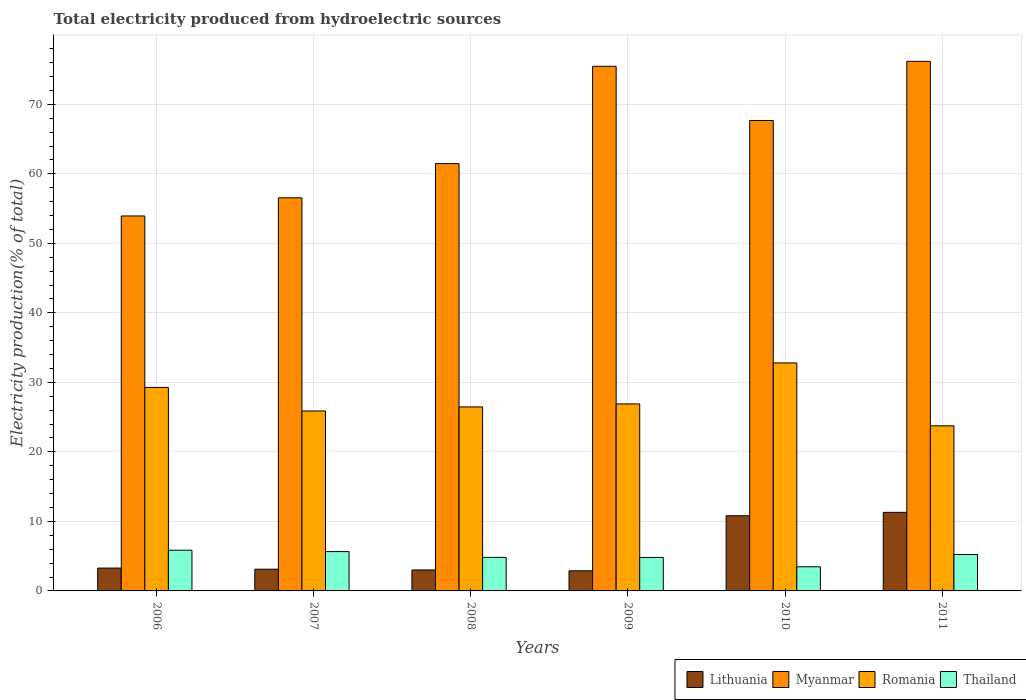How many groups of bars are there?
Your answer should be compact. 6. Are the number of bars on each tick of the X-axis equal?
Make the answer very short. Yes. What is the label of the 1st group of bars from the left?
Make the answer very short. 2006. In how many cases, is the number of bars for a given year not equal to the number of legend labels?
Offer a terse response. 0. What is the total electricity produced in Myanmar in 2008?
Offer a very short reply. 61.48. Across all years, what is the maximum total electricity produced in Romania?
Keep it short and to the point. 32.8. Across all years, what is the minimum total electricity produced in Thailand?
Your answer should be compact. 3.47. In which year was the total electricity produced in Lithuania maximum?
Your answer should be compact. 2011. In which year was the total electricity produced in Lithuania minimum?
Give a very brief answer. 2009. What is the total total electricity produced in Thailand in the graph?
Keep it short and to the point. 29.86. What is the difference between the total electricity produced in Myanmar in 2007 and that in 2009?
Your answer should be very brief. -18.92. What is the difference between the total electricity produced in Lithuania in 2007 and the total electricity produced in Myanmar in 2009?
Make the answer very short. -72.35. What is the average total electricity produced in Romania per year?
Provide a succinct answer. 27.52. In the year 2010, what is the difference between the total electricity produced in Romania and total electricity produced in Lithuania?
Give a very brief answer. 21.99. What is the ratio of the total electricity produced in Romania in 2007 to that in 2011?
Offer a terse response. 1.09. Is the total electricity produced in Lithuania in 2006 less than that in 2007?
Offer a very short reply. No. Is the difference between the total electricity produced in Romania in 2007 and 2011 greater than the difference between the total electricity produced in Lithuania in 2007 and 2011?
Ensure brevity in your answer.  Yes. What is the difference between the highest and the second highest total electricity produced in Thailand?
Your response must be concise. 0.2. What is the difference between the highest and the lowest total electricity produced in Thailand?
Keep it short and to the point. 2.39. In how many years, is the total electricity produced in Myanmar greater than the average total electricity produced in Myanmar taken over all years?
Give a very brief answer. 3. What does the 2nd bar from the left in 2010 represents?
Make the answer very short. Myanmar. What does the 4th bar from the right in 2010 represents?
Your response must be concise. Lithuania. How many bars are there?
Your response must be concise. 24. How many years are there in the graph?
Keep it short and to the point. 6. What is the difference between two consecutive major ticks on the Y-axis?
Your answer should be very brief. 10. Does the graph contain any zero values?
Keep it short and to the point. No. What is the title of the graph?
Your response must be concise. Total electricity produced from hydroelectric sources. What is the label or title of the Y-axis?
Your answer should be very brief. Electricity production(% of total). What is the Electricity production(% of total) in Lithuania in 2006?
Make the answer very short. 3.29. What is the Electricity production(% of total) of Myanmar in 2006?
Your answer should be compact. 53.94. What is the Electricity production(% of total) in Romania in 2006?
Offer a very short reply. 29.28. What is the Electricity production(% of total) of Thailand in 2006?
Your response must be concise. 5.86. What is the Electricity production(% of total) in Lithuania in 2007?
Offer a very short reply. 3.13. What is the Electricity production(% of total) of Myanmar in 2007?
Provide a short and direct response. 56.56. What is the Electricity production(% of total) in Romania in 2007?
Provide a succinct answer. 25.89. What is the Electricity production(% of total) in Thailand in 2007?
Offer a terse response. 5.66. What is the Electricity production(% of total) of Lithuania in 2008?
Your answer should be compact. 3.02. What is the Electricity production(% of total) in Myanmar in 2008?
Provide a short and direct response. 61.48. What is the Electricity production(% of total) in Romania in 2008?
Your answer should be very brief. 26.47. What is the Electricity production(% of total) of Thailand in 2008?
Provide a short and direct response. 4.82. What is the Electricity production(% of total) in Lithuania in 2009?
Give a very brief answer. 2.9. What is the Electricity production(% of total) in Myanmar in 2009?
Offer a terse response. 75.47. What is the Electricity production(% of total) in Romania in 2009?
Offer a terse response. 26.9. What is the Electricity production(% of total) in Thailand in 2009?
Your answer should be very brief. 4.82. What is the Electricity production(% of total) of Lithuania in 2010?
Provide a short and direct response. 10.81. What is the Electricity production(% of total) of Myanmar in 2010?
Give a very brief answer. 67.68. What is the Electricity production(% of total) of Romania in 2010?
Give a very brief answer. 32.8. What is the Electricity production(% of total) of Thailand in 2010?
Provide a succinct answer. 3.47. What is the Electricity production(% of total) in Lithuania in 2011?
Offer a terse response. 11.3. What is the Electricity production(% of total) of Myanmar in 2011?
Your answer should be compact. 76.19. What is the Electricity production(% of total) in Romania in 2011?
Make the answer very short. 23.76. What is the Electricity production(% of total) of Thailand in 2011?
Keep it short and to the point. 5.23. Across all years, what is the maximum Electricity production(% of total) in Lithuania?
Offer a very short reply. 11.3. Across all years, what is the maximum Electricity production(% of total) in Myanmar?
Your answer should be compact. 76.19. Across all years, what is the maximum Electricity production(% of total) in Romania?
Make the answer very short. 32.8. Across all years, what is the maximum Electricity production(% of total) in Thailand?
Offer a very short reply. 5.86. Across all years, what is the minimum Electricity production(% of total) in Lithuania?
Your answer should be very brief. 2.9. Across all years, what is the minimum Electricity production(% of total) of Myanmar?
Keep it short and to the point. 53.94. Across all years, what is the minimum Electricity production(% of total) of Romania?
Offer a terse response. 23.76. Across all years, what is the minimum Electricity production(% of total) in Thailand?
Keep it short and to the point. 3.47. What is the total Electricity production(% of total) in Lithuania in the graph?
Ensure brevity in your answer.  34.44. What is the total Electricity production(% of total) of Myanmar in the graph?
Your answer should be compact. 391.31. What is the total Electricity production(% of total) of Romania in the graph?
Make the answer very short. 165.1. What is the total Electricity production(% of total) of Thailand in the graph?
Your answer should be very brief. 29.86. What is the difference between the Electricity production(% of total) of Lithuania in 2006 and that in 2007?
Keep it short and to the point. 0.16. What is the difference between the Electricity production(% of total) in Myanmar in 2006 and that in 2007?
Your answer should be very brief. -2.61. What is the difference between the Electricity production(% of total) in Romania in 2006 and that in 2007?
Your answer should be very brief. 3.39. What is the difference between the Electricity production(% of total) of Thailand in 2006 and that in 2007?
Offer a very short reply. 0.2. What is the difference between the Electricity production(% of total) in Lithuania in 2006 and that in 2008?
Give a very brief answer. 0.27. What is the difference between the Electricity production(% of total) in Myanmar in 2006 and that in 2008?
Keep it short and to the point. -7.53. What is the difference between the Electricity production(% of total) in Romania in 2006 and that in 2008?
Ensure brevity in your answer.  2.81. What is the difference between the Electricity production(% of total) in Thailand in 2006 and that in 2008?
Your answer should be compact. 1.03. What is the difference between the Electricity production(% of total) of Lithuania in 2006 and that in 2009?
Offer a terse response. 0.39. What is the difference between the Electricity production(% of total) in Myanmar in 2006 and that in 2009?
Offer a very short reply. -21.53. What is the difference between the Electricity production(% of total) of Romania in 2006 and that in 2009?
Make the answer very short. 2.37. What is the difference between the Electricity production(% of total) in Thailand in 2006 and that in 2009?
Provide a succinct answer. 1.04. What is the difference between the Electricity production(% of total) in Lithuania in 2006 and that in 2010?
Offer a very short reply. -7.53. What is the difference between the Electricity production(% of total) of Myanmar in 2006 and that in 2010?
Your response must be concise. -13.74. What is the difference between the Electricity production(% of total) of Romania in 2006 and that in 2010?
Your answer should be compact. -3.52. What is the difference between the Electricity production(% of total) of Thailand in 2006 and that in 2010?
Ensure brevity in your answer.  2.39. What is the difference between the Electricity production(% of total) of Lithuania in 2006 and that in 2011?
Your answer should be very brief. -8.02. What is the difference between the Electricity production(% of total) of Myanmar in 2006 and that in 2011?
Offer a very short reply. -22.24. What is the difference between the Electricity production(% of total) of Romania in 2006 and that in 2011?
Your answer should be compact. 5.52. What is the difference between the Electricity production(% of total) in Thailand in 2006 and that in 2011?
Your answer should be very brief. 0.62. What is the difference between the Electricity production(% of total) in Lithuania in 2007 and that in 2008?
Ensure brevity in your answer.  0.11. What is the difference between the Electricity production(% of total) in Myanmar in 2007 and that in 2008?
Keep it short and to the point. -4.92. What is the difference between the Electricity production(% of total) in Romania in 2007 and that in 2008?
Offer a terse response. -0.58. What is the difference between the Electricity production(% of total) in Thailand in 2007 and that in 2008?
Your answer should be very brief. 0.83. What is the difference between the Electricity production(% of total) in Lithuania in 2007 and that in 2009?
Give a very brief answer. 0.23. What is the difference between the Electricity production(% of total) of Myanmar in 2007 and that in 2009?
Your response must be concise. -18.92. What is the difference between the Electricity production(% of total) in Romania in 2007 and that in 2009?
Ensure brevity in your answer.  -1.01. What is the difference between the Electricity production(% of total) of Thailand in 2007 and that in 2009?
Make the answer very short. 0.84. What is the difference between the Electricity production(% of total) of Lithuania in 2007 and that in 2010?
Your answer should be compact. -7.69. What is the difference between the Electricity production(% of total) in Myanmar in 2007 and that in 2010?
Give a very brief answer. -11.12. What is the difference between the Electricity production(% of total) in Romania in 2007 and that in 2010?
Your response must be concise. -6.91. What is the difference between the Electricity production(% of total) of Thailand in 2007 and that in 2010?
Your answer should be very brief. 2.19. What is the difference between the Electricity production(% of total) of Lithuania in 2007 and that in 2011?
Your answer should be compact. -8.18. What is the difference between the Electricity production(% of total) in Myanmar in 2007 and that in 2011?
Offer a very short reply. -19.63. What is the difference between the Electricity production(% of total) in Romania in 2007 and that in 2011?
Your response must be concise. 2.13. What is the difference between the Electricity production(% of total) of Thailand in 2007 and that in 2011?
Your response must be concise. 0.43. What is the difference between the Electricity production(% of total) in Lithuania in 2008 and that in 2009?
Ensure brevity in your answer.  0.12. What is the difference between the Electricity production(% of total) in Myanmar in 2008 and that in 2009?
Your answer should be very brief. -14. What is the difference between the Electricity production(% of total) of Romania in 2008 and that in 2009?
Your answer should be very brief. -0.43. What is the difference between the Electricity production(% of total) of Thailand in 2008 and that in 2009?
Ensure brevity in your answer.  0.01. What is the difference between the Electricity production(% of total) in Lithuania in 2008 and that in 2010?
Give a very brief answer. -7.8. What is the difference between the Electricity production(% of total) of Myanmar in 2008 and that in 2010?
Ensure brevity in your answer.  -6.2. What is the difference between the Electricity production(% of total) in Romania in 2008 and that in 2010?
Your answer should be compact. -6.33. What is the difference between the Electricity production(% of total) in Thailand in 2008 and that in 2010?
Your answer should be compact. 1.35. What is the difference between the Electricity production(% of total) of Lithuania in 2008 and that in 2011?
Provide a short and direct response. -8.29. What is the difference between the Electricity production(% of total) of Myanmar in 2008 and that in 2011?
Provide a short and direct response. -14.71. What is the difference between the Electricity production(% of total) of Romania in 2008 and that in 2011?
Provide a succinct answer. 2.72. What is the difference between the Electricity production(% of total) of Thailand in 2008 and that in 2011?
Your answer should be very brief. -0.41. What is the difference between the Electricity production(% of total) of Lithuania in 2009 and that in 2010?
Give a very brief answer. -7.92. What is the difference between the Electricity production(% of total) in Myanmar in 2009 and that in 2010?
Provide a short and direct response. 7.8. What is the difference between the Electricity production(% of total) of Romania in 2009 and that in 2010?
Offer a terse response. -5.9. What is the difference between the Electricity production(% of total) of Thailand in 2009 and that in 2010?
Offer a very short reply. 1.35. What is the difference between the Electricity production(% of total) of Lithuania in 2009 and that in 2011?
Ensure brevity in your answer.  -8.41. What is the difference between the Electricity production(% of total) of Myanmar in 2009 and that in 2011?
Offer a terse response. -0.71. What is the difference between the Electricity production(% of total) in Romania in 2009 and that in 2011?
Your answer should be very brief. 3.15. What is the difference between the Electricity production(% of total) of Thailand in 2009 and that in 2011?
Provide a short and direct response. -0.42. What is the difference between the Electricity production(% of total) of Lithuania in 2010 and that in 2011?
Offer a very short reply. -0.49. What is the difference between the Electricity production(% of total) in Myanmar in 2010 and that in 2011?
Offer a terse response. -8.51. What is the difference between the Electricity production(% of total) in Romania in 2010 and that in 2011?
Your answer should be compact. 9.04. What is the difference between the Electricity production(% of total) in Thailand in 2010 and that in 2011?
Provide a succinct answer. -1.76. What is the difference between the Electricity production(% of total) in Lithuania in 2006 and the Electricity production(% of total) in Myanmar in 2007?
Provide a short and direct response. -53.27. What is the difference between the Electricity production(% of total) of Lithuania in 2006 and the Electricity production(% of total) of Romania in 2007?
Your answer should be very brief. -22.6. What is the difference between the Electricity production(% of total) of Lithuania in 2006 and the Electricity production(% of total) of Thailand in 2007?
Keep it short and to the point. -2.37. What is the difference between the Electricity production(% of total) in Myanmar in 2006 and the Electricity production(% of total) in Romania in 2007?
Make the answer very short. 28.05. What is the difference between the Electricity production(% of total) in Myanmar in 2006 and the Electricity production(% of total) in Thailand in 2007?
Give a very brief answer. 48.28. What is the difference between the Electricity production(% of total) of Romania in 2006 and the Electricity production(% of total) of Thailand in 2007?
Give a very brief answer. 23.62. What is the difference between the Electricity production(% of total) of Lithuania in 2006 and the Electricity production(% of total) of Myanmar in 2008?
Ensure brevity in your answer.  -58.19. What is the difference between the Electricity production(% of total) in Lithuania in 2006 and the Electricity production(% of total) in Romania in 2008?
Make the answer very short. -23.18. What is the difference between the Electricity production(% of total) of Lithuania in 2006 and the Electricity production(% of total) of Thailand in 2008?
Your answer should be compact. -1.54. What is the difference between the Electricity production(% of total) of Myanmar in 2006 and the Electricity production(% of total) of Romania in 2008?
Offer a very short reply. 27.47. What is the difference between the Electricity production(% of total) of Myanmar in 2006 and the Electricity production(% of total) of Thailand in 2008?
Make the answer very short. 49.12. What is the difference between the Electricity production(% of total) of Romania in 2006 and the Electricity production(% of total) of Thailand in 2008?
Make the answer very short. 24.45. What is the difference between the Electricity production(% of total) in Lithuania in 2006 and the Electricity production(% of total) in Myanmar in 2009?
Give a very brief answer. -72.19. What is the difference between the Electricity production(% of total) of Lithuania in 2006 and the Electricity production(% of total) of Romania in 2009?
Make the answer very short. -23.62. What is the difference between the Electricity production(% of total) in Lithuania in 2006 and the Electricity production(% of total) in Thailand in 2009?
Your answer should be very brief. -1.53. What is the difference between the Electricity production(% of total) of Myanmar in 2006 and the Electricity production(% of total) of Romania in 2009?
Provide a succinct answer. 27.04. What is the difference between the Electricity production(% of total) of Myanmar in 2006 and the Electricity production(% of total) of Thailand in 2009?
Make the answer very short. 49.13. What is the difference between the Electricity production(% of total) of Romania in 2006 and the Electricity production(% of total) of Thailand in 2009?
Your answer should be very brief. 24.46. What is the difference between the Electricity production(% of total) in Lithuania in 2006 and the Electricity production(% of total) in Myanmar in 2010?
Keep it short and to the point. -64.39. What is the difference between the Electricity production(% of total) of Lithuania in 2006 and the Electricity production(% of total) of Romania in 2010?
Offer a very short reply. -29.51. What is the difference between the Electricity production(% of total) in Lithuania in 2006 and the Electricity production(% of total) in Thailand in 2010?
Keep it short and to the point. -0.18. What is the difference between the Electricity production(% of total) in Myanmar in 2006 and the Electricity production(% of total) in Romania in 2010?
Provide a succinct answer. 21.14. What is the difference between the Electricity production(% of total) in Myanmar in 2006 and the Electricity production(% of total) in Thailand in 2010?
Your response must be concise. 50.47. What is the difference between the Electricity production(% of total) of Romania in 2006 and the Electricity production(% of total) of Thailand in 2010?
Give a very brief answer. 25.81. What is the difference between the Electricity production(% of total) in Lithuania in 2006 and the Electricity production(% of total) in Myanmar in 2011?
Offer a very short reply. -72.9. What is the difference between the Electricity production(% of total) of Lithuania in 2006 and the Electricity production(% of total) of Romania in 2011?
Give a very brief answer. -20.47. What is the difference between the Electricity production(% of total) in Lithuania in 2006 and the Electricity production(% of total) in Thailand in 2011?
Your response must be concise. -1.95. What is the difference between the Electricity production(% of total) in Myanmar in 2006 and the Electricity production(% of total) in Romania in 2011?
Your response must be concise. 30.19. What is the difference between the Electricity production(% of total) in Myanmar in 2006 and the Electricity production(% of total) in Thailand in 2011?
Your answer should be very brief. 48.71. What is the difference between the Electricity production(% of total) in Romania in 2006 and the Electricity production(% of total) in Thailand in 2011?
Provide a short and direct response. 24.04. What is the difference between the Electricity production(% of total) of Lithuania in 2007 and the Electricity production(% of total) of Myanmar in 2008?
Provide a succinct answer. -58.35. What is the difference between the Electricity production(% of total) in Lithuania in 2007 and the Electricity production(% of total) in Romania in 2008?
Keep it short and to the point. -23.35. What is the difference between the Electricity production(% of total) of Lithuania in 2007 and the Electricity production(% of total) of Thailand in 2008?
Your response must be concise. -1.7. What is the difference between the Electricity production(% of total) of Myanmar in 2007 and the Electricity production(% of total) of Romania in 2008?
Your answer should be compact. 30.08. What is the difference between the Electricity production(% of total) of Myanmar in 2007 and the Electricity production(% of total) of Thailand in 2008?
Ensure brevity in your answer.  51.73. What is the difference between the Electricity production(% of total) in Romania in 2007 and the Electricity production(% of total) in Thailand in 2008?
Provide a short and direct response. 21.06. What is the difference between the Electricity production(% of total) in Lithuania in 2007 and the Electricity production(% of total) in Myanmar in 2009?
Give a very brief answer. -72.35. What is the difference between the Electricity production(% of total) of Lithuania in 2007 and the Electricity production(% of total) of Romania in 2009?
Your answer should be very brief. -23.78. What is the difference between the Electricity production(% of total) in Lithuania in 2007 and the Electricity production(% of total) in Thailand in 2009?
Offer a terse response. -1.69. What is the difference between the Electricity production(% of total) in Myanmar in 2007 and the Electricity production(% of total) in Romania in 2009?
Your answer should be compact. 29.65. What is the difference between the Electricity production(% of total) of Myanmar in 2007 and the Electricity production(% of total) of Thailand in 2009?
Keep it short and to the point. 51.74. What is the difference between the Electricity production(% of total) of Romania in 2007 and the Electricity production(% of total) of Thailand in 2009?
Ensure brevity in your answer.  21.07. What is the difference between the Electricity production(% of total) in Lithuania in 2007 and the Electricity production(% of total) in Myanmar in 2010?
Keep it short and to the point. -64.55. What is the difference between the Electricity production(% of total) of Lithuania in 2007 and the Electricity production(% of total) of Romania in 2010?
Provide a short and direct response. -29.67. What is the difference between the Electricity production(% of total) in Lithuania in 2007 and the Electricity production(% of total) in Thailand in 2010?
Ensure brevity in your answer.  -0.35. What is the difference between the Electricity production(% of total) in Myanmar in 2007 and the Electricity production(% of total) in Romania in 2010?
Provide a short and direct response. 23.76. What is the difference between the Electricity production(% of total) of Myanmar in 2007 and the Electricity production(% of total) of Thailand in 2010?
Your response must be concise. 53.08. What is the difference between the Electricity production(% of total) of Romania in 2007 and the Electricity production(% of total) of Thailand in 2010?
Your answer should be compact. 22.42. What is the difference between the Electricity production(% of total) of Lithuania in 2007 and the Electricity production(% of total) of Myanmar in 2011?
Make the answer very short. -73.06. What is the difference between the Electricity production(% of total) of Lithuania in 2007 and the Electricity production(% of total) of Romania in 2011?
Your answer should be very brief. -20.63. What is the difference between the Electricity production(% of total) of Lithuania in 2007 and the Electricity production(% of total) of Thailand in 2011?
Offer a very short reply. -2.11. What is the difference between the Electricity production(% of total) in Myanmar in 2007 and the Electricity production(% of total) in Romania in 2011?
Your response must be concise. 32.8. What is the difference between the Electricity production(% of total) of Myanmar in 2007 and the Electricity production(% of total) of Thailand in 2011?
Your response must be concise. 51.32. What is the difference between the Electricity production(% of total) of Romania in 2007 and the Electricity production(% of total) of Thailand in 2011?
Offer a very short reply. 20.66. What is the difference between the Electricity production(% of total) in Lithuania in 2008 and the Electricity production(% of total) in Myanmar in 2009?
Provide a succinct answer. -72.46. What is the difference between the Electricity production(% of total) of Lithuania in 2008 and the Electricity production(% of total) of Romania in 2009?
Provide a succinct answer. -23.89. What is the difference between the Electricity production(% of total) in Lithuania in 2008 and the Electricity production(% of total) in Thailand in 2009?
Give a very brief answer. -1.8. What is the difference between the Electricity production(% of total) of Myanmar in 2008 and the Electricity production(% of total) of Romania in 2009?
Give a very brief answer. 34.57. What is the difference between the Electricity production(% of total) in Myanmar in 2008 and the Electricity production(% of total) in Thailand in 2009?
Provide a succinct answer. 56.66. What is the difference between the Electricity production(% of total) in Romania in 2008 and the Electricity production(% of total) in Thailand in 2009?
Keep it short and to the point. 21.65. What is the difference between the Electricity production(% of total) in Lithuania in 2008 and the Electricity production(% of total) in Myanmar in 2010?
Make the answer very short. -64.66. What is the difference between the Electricity production(% of total) of Lithuania in 2008 and the Electricity production(% of total) of Romania in 2010?
Make the answer very short. -29.78. What is the difference between the Electricity production(% of total) in Lithuania in 2008 and the Electricity production(% of total) in Thailand in 2010?
Your answer should be compact. -0.45. What is the difference between the Electricity production(% of total) in Myanmar in 2008 and the Electricity production(% of total) in Romania in 2010?
Your answer should be very brief. 28.68. What is the difference between the Electricity production(% of total) of Myanmar in 2008 and the Electricity production(% of total) of Thailand in 2010?
Offer a terse response. 58.01. What is the difference between the Electricity production(% of total) of Romania in 2008 and the Electricity production(% of total) of Thailand in 2010?
Provide a succinct answer. 23. What is the difference between the Electricity production(% of total) in Lithuania in 2008 and the Electricity production(% of total) in Myanmar in 2011?
Your answer should be very brief. -73.17. What is the difference between the Electricity production(% of total) in Lithuania in 2008 and the Electricity production(% of total) in Romania in 2011?
Ensure brevity in your answer.  -20.74. What is the difference between the Electricity production(% of total) of Lithuania in 2008 and the Electricity production(% of total) of Thailand in 2011?
Your response must be concise. -2.22. What is the difference between the Electricity production(% of total) of Myanmar in 2008 and the Electricity production(% of total) of Romania in 2011?
Keep it short and to the point. 37.72. What is the difference between the Electricity production(% of total) of Myanmar in 2008 and the Electricity production(% of total) of Thailand in 2011?
Ensure brevity in your answer.  56.24. What is the difference between the Electricity production(% of total) in Romania in 2008 and the Electricity production(% of total) in Thailand in 2011?
Provide a succinct answer. 21.24. What is the difference between the Electricity production(% of total) in Lithuania in 2009 and the Electricity production(% of total) in Myanmar in 2010?
Your answer should be very brief. -64.78. What is the difference between the Electricity production(% of total) in Lithuania in 2009 and the Electricity production(% of total) in Romania in 2010?
Offer a terse response. -29.9. What is the difference between the Electricity production(% of total) of Lithuania in 2009 and the Electricity production(% of total) of Thailand in 2010?
Your response must be concise. -0.58. What is the difference between the Electricity production(% of total) of Myanmar in 2009 and the Electricity production(% of total) of Romania in 2010?
Ensure brevity in your answer.  42.67. What is the difference between the Electricity production(% of total) in Myanmar in 2009 and the Electricity production(% of total) in Thailand in 2010?
Offer a very short reply. 72. What is the difference between the Electricity production(% of total) of Romania in 2009 and the Electricity production(% of total) of Thailand in 2010?
Make the answer very short. 23.43. What is the difference between the Electricity production(% of total) in Lithuania in 2009 and the Electricity production(% of total) in Myanmar in 2011?
Offer a very short reply. -73.29. What is the difference between the Electricity production(% of total) in Lithuania in 2009 and the Electricity production(% of total) in Romania in 2011?
Offer a terse response. -20.86. What is the difference between the Electricity production(% of total) of Lithuania in 2009 and the Electricity production(% of total) of Thailand in 2011?
Your response must be concise. -2.34. What is the difference between the Electricity production(% of total) of Myanmar in 2009 and the Electricity production(% of total) of Romania in 2011?
Provide a short and direct response. 51.72. What is the difference between the Electricity production(% of total) of Myanmar in 2009 and the Electricity production(% of total) of Thailand in 2011?
Your answer should be compact. 70.24. What is the difference between the Electricity production(% of total) of Romania in 2009 and the Electricity production(% of total) of Thailand in 2011?
Your response must be concise. 21.67. What is the difference between the Electricity production(% of total) in Lithuania in 2010 and the Electricity production(% of total) in Myanmar in 2011?
Provide a succinct answer. -65.37. What is the difference between the Electricity production(% of total) in Lithuania in 2010 and the Electricity production(% of total) in Romania in 2011?
Your answer should be very brief. -12.94. What is the difference between the Electricity production(% of total) in Lithuania in 2010 and the Electricity production(% of total) in Thailand in 2011?
Provide a succinct answer. 5.58. What is the difference between the Electricity production(% of total) in Myanmar in 2010 and the Electricity production(% of total) in Romania in 2011?
Offer a very short reply. 43.92. What is the difference between the Electricity production(% of total) in Myanmar in 2010 and the Electricity production(% of total) in Thailand in 2011?
Keep it short and to the point. 62.45. What is the difference between the Electricity production(% of total) of Romania in 2010 and the Electricity production(% of total) of Thailand in 2011?
Your response must be concise. 27.57. What is the average Electricity production(% of total) in Lithuania per year?
Give a very brief answer. 5.74. What is the average Electricity production(% of total) in Myanmar per year?
Give a very brief answer. 65.22. What is the average Electricity production(% of total) in Romania per year?
Your answer should be compact. 27.52. What is the average Electricity production(% of total) of Thailand per year?
Offer a terse response. 4.98. In the year 2006, what is the difference between the Electricity production(% of total) of Lithuania and Electricity production(% of total) of Myanmar?
Your answer should be compact. -50.66. In the year 2006, what is the difference between the Electricity production(% of total) in Lithuania and Electricity production(% of total) in Romania?
Offer a very short reply. -25.99. In the year 2006, what is the difference between the Electricity production(% of total) in Lithuania and Electricity production(% of total) in Thailand?
Offer a terse response. -2.57. In the year 2006, what is the difference between the Electricity production(% of total) of Myanmar and Electricity production(% of total) of Romania?
Your response must be concise. 24.66. In the year 2006, what is the difference between the Electricity production(% of total) in Myanmar and Electricity production(% of total) in Thailand?
Provide a succinct answer. 48.09. In the year 2006, what is the difference between the Electricity production(% of total) of Romania and Electricity production(% of total) of Thailand?
Your response must be concise. 23.42. In the year 2007, what is the difference between the Electricity production(% of total) in Lithuania and Electricity production(% of total) in Myanmar?
Keep it short and to the point. -53.43. In the year 2007, what is the difference between the Electricity production(% of total) of Lithuania and Electricity production(% of total) of Romania?
Your answer should be very brief. -22.76. In the year 2007, what is the difference between the Electricity production(% of total) in Lithuania and Electricity production(% of total) in Thailand?
Provide a short and direct response. -2.53. In the year 2007, what is the difference between the Electricity production(% of total) of Myanmar and Electricity production(% of total) of Romania?
Give a very brief answer. 30.67. In the year 2007, what is the difference between the Electricity production(% of total) in Myanmar and Electricity production(% of total) in Thailand?
Your response must be concise. 50.9. In the year 2007, what is the difference between the Electricity production(% of total) of Romania and Electricity production(% of total) of Thailand?
Provide a short and direct response. 20.23. In the year 2008, what is the difference between the Electricity production(% of total) in Lithuania and Electricity production(% of total) in Myanmar?
Your answer should be compact. -58.46. In the year 2008, what is the difference between the Electricity production(% of total) of Lithuania and Electricity production(% of total) of Romania?
Offer a terse response. -23.46. In the year 2008, what is the difference between the Electricity production(% of total) in Lithuania and Electricity production(% of total) in Thailand?
Your answer should be compact. -1.81. In the year 2008, what is the difference between the Electricity production(% of total) in Myanmar and Electricity production(% of total) in Romania?
Your answer should be very brief. 35.01. In the year 2008, what is the difference between the Electricity production(% of total) of Myanmar and Electricity production(% of total) of Thailand?
Offer a terse response. 56.65. In the year 2008, what is the difference between the Electricity production(% of total) of Romania and Electricity production(% of total) of Thailand?
Offer a terse response. 21.65. In the year 2009, what is the difference between the Electricity production(% of total) in Lithuania and Electricity production(% of total) in Myanmar?
Offer a terse response. -72.58. In the year 2009, what is the difference between the Electricity production(% of total) in Lithuania and Electricity production(% of total) in Romania?
Provide a succinct answer. -24.01. In the year 2009, what is the difference between the Electricity production(% of total) of Lithuania and Electricity production(% of total) of Thailand?
Your answer should be very brief. -1.92. In the year 2009, what is the difference between the Electricity production(% of total) in Myanmar and Electricity production(% of total) in Romania?
Keep it short and to the point. 48.57. In the year 2009, what is the difference between the Electricity production(% of total) in Myanmar and Electricity production(% of total) in Thailand?
Provide a short and direct response. 70.66. In the year 2009, what is the difference between the Electricity production(% of total) in Romania and Electricity production(% of total) in Thailand?
Provide a succinct answer. 22.09. In the year 2010, what is the difference between the Electricity production(% of total) of Lithuania and Electricity production(% of total) of Myanmar?
Your answer should be compact. -56.87. In the year 2010, what is the difference between the Electricity production(% of total) in Lithuania and Electricity production(% of total) in Romania?
Ensure brevity in your answer.  -21.99. In the year 2010, what is the difference between the Electricity production(% of total) in Lithuania and Electricity production(% of total) in Thailand?
Your answer should be compact. 7.34. In the year 2010, what is the difference between the Electricity production(% of total) in Myanmar and Electricity production(% of total) in Romania?
Ensure brevity in your answer.  34.88. In the year 2010, what is the difference between the Electricity production(% of total) of Myanmar and Electricity production(% of total) of Thailand?
Make the answer very short. 64.21. In the year 2010, what is the difference between the Electricity production(% of total) in Romania and Electricity production(% of total) in Thailand?
Offer a very short reply. 29.33. In the year 2011, what is the difference between the Electricity production(% of total) of Lithuania and Electricity production(% of total) of Myanmar?
Provide a succinct answer. -64.88. In the year 2011, what is the difference between the Electricity production(% of total) of Lithuania and Electricity production(% of total) of Romania?
Provide a short and direct response. -12.45. In the year 2011, what is the difference between the Electricity production(% of total) in Lithuania and Electricity production(% of total) in Thailand?
Your answer should be compact. 6.07. In the year 2011, what is the difference between the Electricity production(% of total) in Myanmar and Electricity production(% of total) in Romania?
Offer a terse response. 52.43. In the year 2011, what is the difference between the Electricity production(% of total) in Myanmar and Electricity production(% of total) in Thailand?
Offer a terse response. 70.95. In the year 2011, what is the difference between the Electricity production(% of total) of Romania and Electricity production(% of total) of Thailand?
Your response must be concise. 18.52. What is the ratio of the Electricity production(% of total) of Lithuania in 2006 to that in 2007?
Keep it short and to the point. 1.05. What is the ratio of the Electricity production(% of total) in Myanmar in 2006 to that in 2007?
Provide a short and direct response. 0.95. What is the ratio of the Electricity production(% of total) in Romania in 2006 to that in 2007?
Keep it short and to the point. 1.13. What is the ratio of the Electricity production(% of total) in Thailand in 2006 to that in 2007?
Your answer should be compact. 1.03. What is the ratio of the Electricity production(% of total) in Lithuania in 2006 to that in 2008?
Provide a short and direct response. 1.09. What is the ratio of the Electricity production(% of total) of Myanmar in 2006 to that in 2008?
Keep it short and to the point. 0.88. What is the ratio of the Electricity production(% of total) of Romania in 2006 to that in 2008?
Give a very brief answer. 1.11. What is the ratio of the Electricity production(% of total) in Thailand in 2006 to that in 2008?
Provide a succinct answer. 1.21. What is the ratio of the Electricity production(% of total) in Lithuania in 2006 to that in 2009?
Your answer should be very brief. 1.14. What is the ratio of the Electricity production(% of total) of Myanmar in 2006 to that in 2009?
Give a very brief answer. 0.71. What is the ratio of the Electricity production(% of total) of Romania in 2006 to that in 2009?
Keep it short and to the point. 1.09. What is the ratio of the Electricity production(% of total) of Thailand in 2006 to that in 2009?
Make the answer very short. 1.22. What is the ratio of the Electricity production(% of total) in Lithuania in 2006 to that in 2010?
Your answer should be compact. 0.3. What is the ratio of the Electricity production(% of total) of Myanmar in 2006 to that in 2010?
Ensure brevity in your answer.  0.8. What is the ratio of the Electricity production(% of total) in Romania in 2006 to that in 2010?
Offer a terse response. 0.89. What is the ratio of the Electricity production(% of total) in Thailand in 2006 to that in 2010?
Keep it short and to the point. 1.69. What is the ratio of the Electricity production(% of total) of Lithuania in 2006 to that in 2011?
Make the answer very short. 0.29. What is the ratio of the Electricity production(% of total) in Myanmar in 2006 to that in 2011?
Offer a terse response. 0.71. What is the ratio of the Electricity production(% of total) in Romania in 2006 to that in 2011?
Keep it short and to the point. 1.23. What is the ratio of the Electricity production(% of total) of Thailand in 2006 to that in 2011?
Give a very brief answer. 1.12. What is the ratio of the Electricity production(% of total) of Lithuania in 2007 to that in 2008?
Your response must be concise. 1.04. What is the ratio of the Electricity production(% of total) of Myanmar in 2007 to that in 2008?
Your response must be concise. 0.92. What is the ratio of the Electricity production(% of total) of Romania in 2007 to that in 2008?
Provide a succinct answer. 0.98. What is the ratio of the Electricity production(% of total) in Thailand in 2007 to that in 2008?
Your answer should be compact. 1.17. What is the ratio of the Electricity production(% of total) in Lithuania in 2007 to that in 2009?
Your answer should be very brief. 1.08. What is the ratio of the Electricity production(% of total) in Myanmar in 2007 to that in 2009?
Provide a short and direct response. 0.75. What is the ratio of the Electricity production(% of total) in Romania in 2007 to that in 2009?
Keep it short and to the point. 0.96. What is the ratio of the Electricity production(% of total) of Thailand in 2007 to that in 2009?
Your response must be concise. 1.17. What is the ratio of the Electricity production(% of total) of Lithuania in 2007 to that in 2010?
Offer a very short reply. 0.29. What is the ratio of the Electricity production(% of total) of Myanmar in 2007 to that in 2010?
Make the answer very short. 0.84. What is the ratio of the Electricity production(% of total) of Romania in 2007 to that in 2010?
Provide a succinct answer. 0.79. What is the ratio of the Electricity production(% of total) of Thailand in 2007 to that in 2010?
Keep it short and to the point. 1.63. What is the ratio of the Electricity production(% of total) of Lithuania in 2007 to that in 2011?
Provide a succinct answer. 0.28. What is the ratio of the Electricity production(% of total) in Myanmar in 2007 to that in 2011?
Provide a short and direct response. 0.74. What is the ratio of the Electricity production(% of total) of Romania in 2007 to that in 2011?
Your response must be concise. 1.09. What is the ratio of the Electricity production(% of total) of Thailand in 2007 to that in 2011?
Ensure brevity in your answer.  1.08. What is the ratio of the Electricity production(% of total) in Lithuania in 2008 to that in 2009?
Ensure brevity in your answer.  1.04. What is the ratio of the Electricity production(% of total) of Myanmar in 2008 to that in 2009?
Keep it short and to the point. 0.81. What is the ratio of the Electricity production(% of total) in Lithuania in 2008 to that in 2010?
Keep it short and to the point. 0.28. What is the ratio of the Electricity production(% of total) of Myanmar in 2008 to that in 2010?
Offer a terse response. 0.91. What is the ratio of the Electricity production(% of total) of Romania in 2008 to that in 2010?
Ensure brevity in your answer.  0.81. What is the ratio of the Electricity production(% of total) in Thailand in 2008 to that in 2010?
Give a very brief answer. 1.39. What is the ratio of the Electricity production(% of total) of Lithuania in 2008 to that in 2011?
Provide a short and direct response. 0.27. What is the ratio of the Electricity production(% of total) of Myanmar in 2008 to that in 2011?
Make the answer very short. 0.81. What is the ratio of the Electricity production(% of total) in Romania in 2008 to that in 2011?
Provide a succinct answer. 1.11. What is the ratio of the Electricity production(% of total) in Thailand in 2008 to that in 2011?
Ensure brevity in your answer.  0.92. What is the ratio of the Electricity production(% of total) of Lithuania in 2009 to that in 2010?
Provide a succinct answer. 0.27. What is the ratio of the Electricity production(% of total) in Myanmar in 2009 to that in 2010?
Provide a short and direct response. 1.12. What is the ratio of the Electricity production(% of total) of Romania in 2009 to that in 2010?
Provide a succinct answer. 0.82. What is the ratio of the Electricity production(% of total) of Thailand in 2009 to that in 2010?
Provide a succinct answer. 1.39. What is the ratio of the Electricity production(% of total) in Lithuania in 2009 to that in 2011?
Your response must be concise. 0.26. What is the ratio of the Electricity production(% of total) of Myanmar in 2009 to that in 2011?
Ensure brevity in your answer.  0.99. What is the ratio of the Electricity production(% of total) in Romania in 2009 to that in 2011?
Make the answer very short. 1.13. What is the ratio of the Electricity production(% of total) of Thailand in 2009 to that in 2011?
Provide a short and direct response. 0.92. What is the ratio of the Electricity production(% of total) of Lithuania in 2010 to that in 2011?
Your answer should be compact. 0.96. What is the ratio of the Electricity production(% of total) in Myanmar in 2010 to that in 2011?
Offer a very short reply. 0.89. What is the ratio of the Electricity production(% of total) of Romania in 2010 to that in 2011?
Provide a succinct answer. 1.38. What is the ratio of the Electricity production(% of total) of Thailand in 2010 to that in 2011?
Your response must be concise. 0.66. What is the difference between the highest and the second highest Electricity production(% of total) of Lithuania?
Give a very brief answer. 0.49. What is the difference between the highest and the second highest Electricity production(% of total) in Myanmar?
Give a very brief answer. 0.71. What is the difference between the highest and the second highest Electricity production(% of total) in Romania?
Ensure brevity in your answer.  3.52. What is the difference between the highest and the second highest Electricity production(% of total) in Thailand?
Ensure brevity in your answer.  0.2. What is the difference between the highest and the lowest Electricity production(% of total) in Lithuania?
Give a very brief answer. 8.41. What is the difference between the highest and the lowest Electricity production(% of total) in Myanmar?
Your response must be concise. 22.24. What is the difference between the highest and the lowest Electricity production(% of total) in Romania?
Keep it short and to the point. 9.04. What is the difference between the highest and the lowest Electricity production(% of total) of Thailand?
Ensure brevity in your answer.  2.39. 